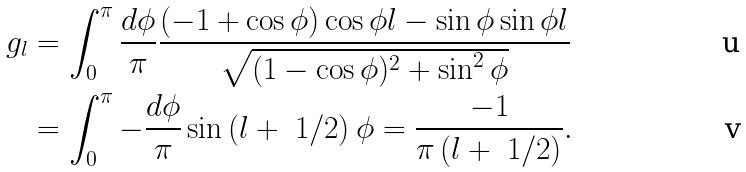<formula> <loc_0><loc_0><loc_500><loc_500>g _ { l } & = \int ^ { \pi } _ { 0 } \frac { d \phi } { \pi } \frac { ( - 1 + \cos { \phi } ) \cos { \phi l } - \sin { \phi } \sin { \phi l } } { \sqrt { ( 1 - \cos { \phi } ) ^ { 2 } + \sin ^ { 2 } { \phi } } } \\ & = \int ^ { \pi } _ { 0 } - \frac { d \phi } { \pi } \sin { \left ( l + \ 1 / 2 \right ) \phi } = \frac { - 1 } { \pi \left ( l + \ 1 / 2 \right ) } .</formula> 